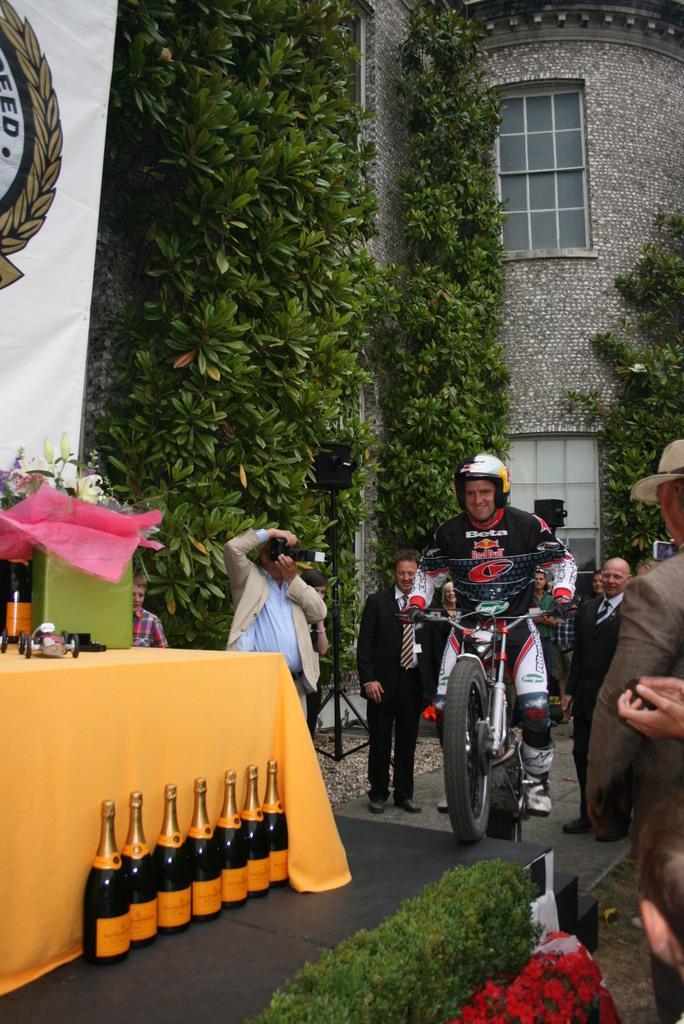Could you give a brief overview of what you see in this image? Here we can see that a person is sitting on the motor cycle, and here there are group of people standing, and here are wine bottles on the stage, and at back here is the table, and here is the tree,and here is the building. 